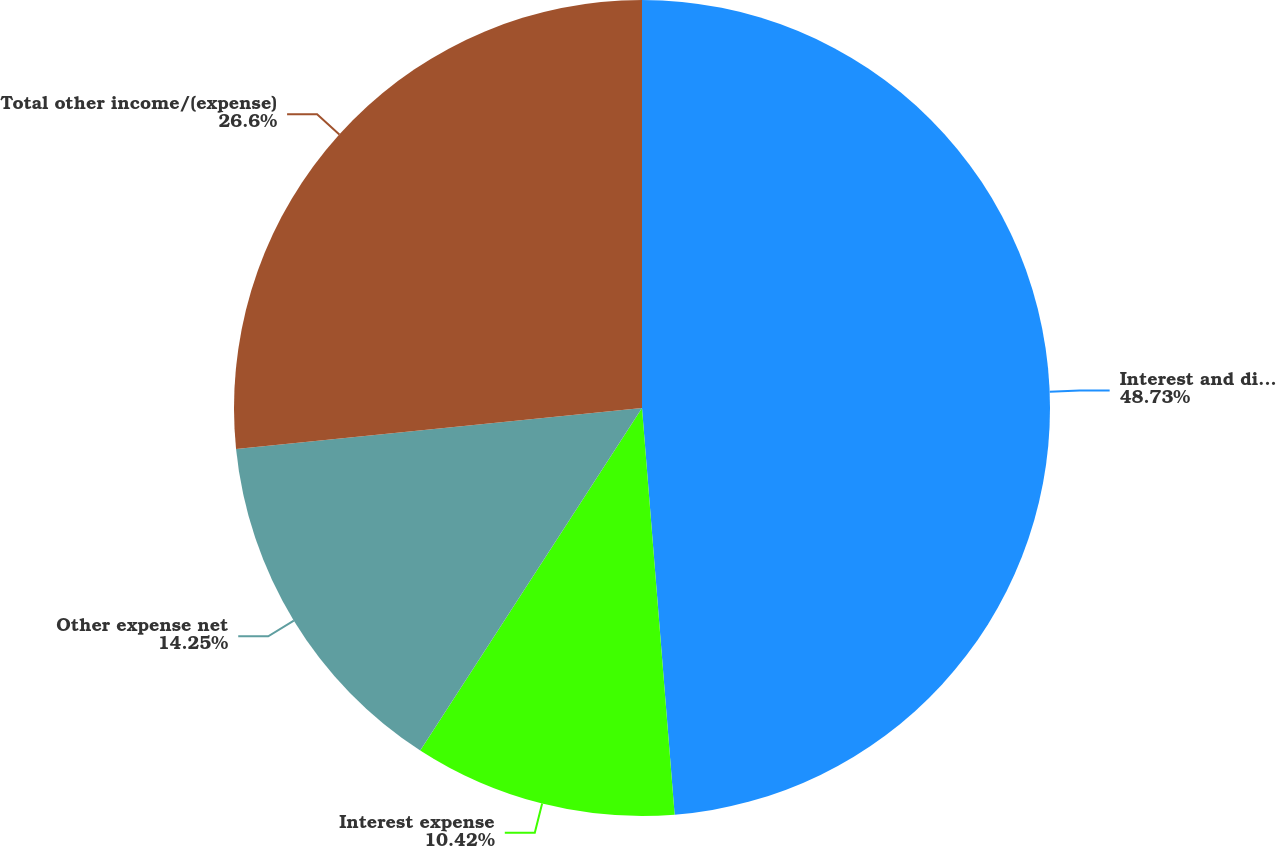Convert chart. <chart><loc_0><loc_0><loc_500><loc_500><pie_chart><fcel>Interest and dividend income<fcel>Interest expense<fcel>Other expense net<fcel>Total other income/(expense)<nl><fcel>48.72%<fcel>10.42%<fcel>14.25%<fcel>26.6%<nl></chart> 